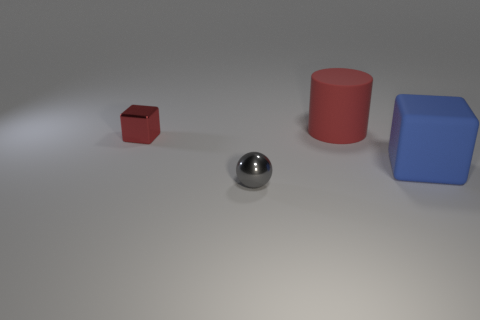Add 1 red shiny blocks. How many objects exist? 5 Add 1 small gray objects. How many small gray objects are left? 2 Add 1 large matte spheres. How many large matte spheres exist? 1 Subtract 0 blue spheres. How many objects are left? 4 Subtract all red cylinders. Subtract all cylinders. How many objects are left? 2 